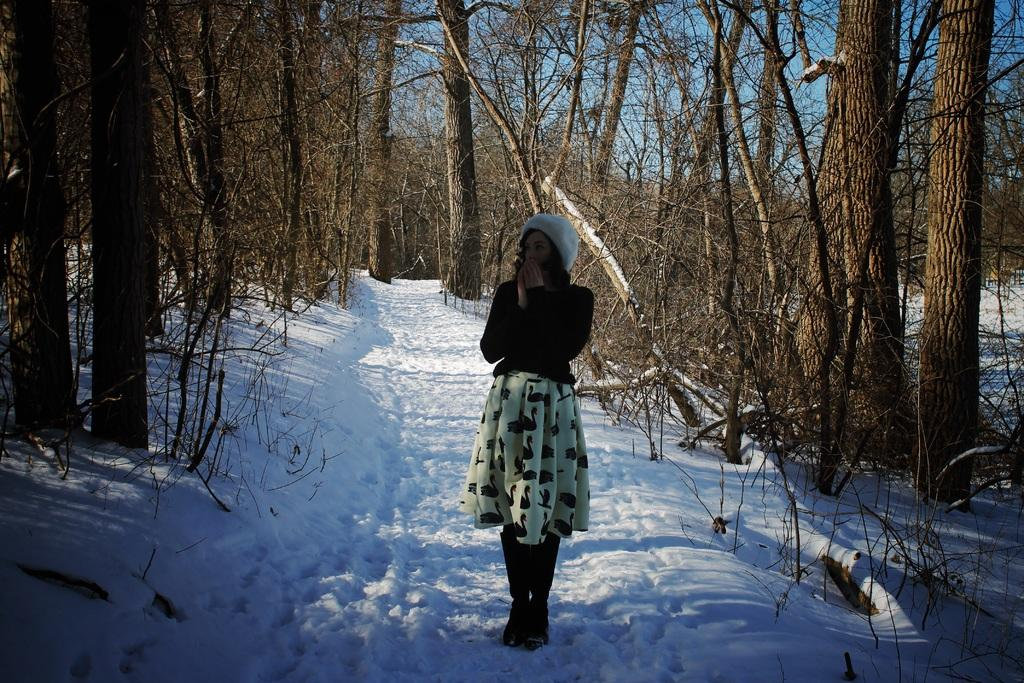Who is present in the image? There is a woman in the image. What is the woman wearing? The woman is wearing a dress. What type of terrain is the woman standing on? The woman is standing on snow. What can be seen in the background of the image? There is a group of trees and the sky visible in the background of the image. What type of quince can be seen in the woman's hand in the image? There is no quince present in the image; the woman is not holding anything. How does the woman measure the depth of the snow in the image? The image does not show the woman measuring the depth of the snow, nor is there any indication that she is doing so. 